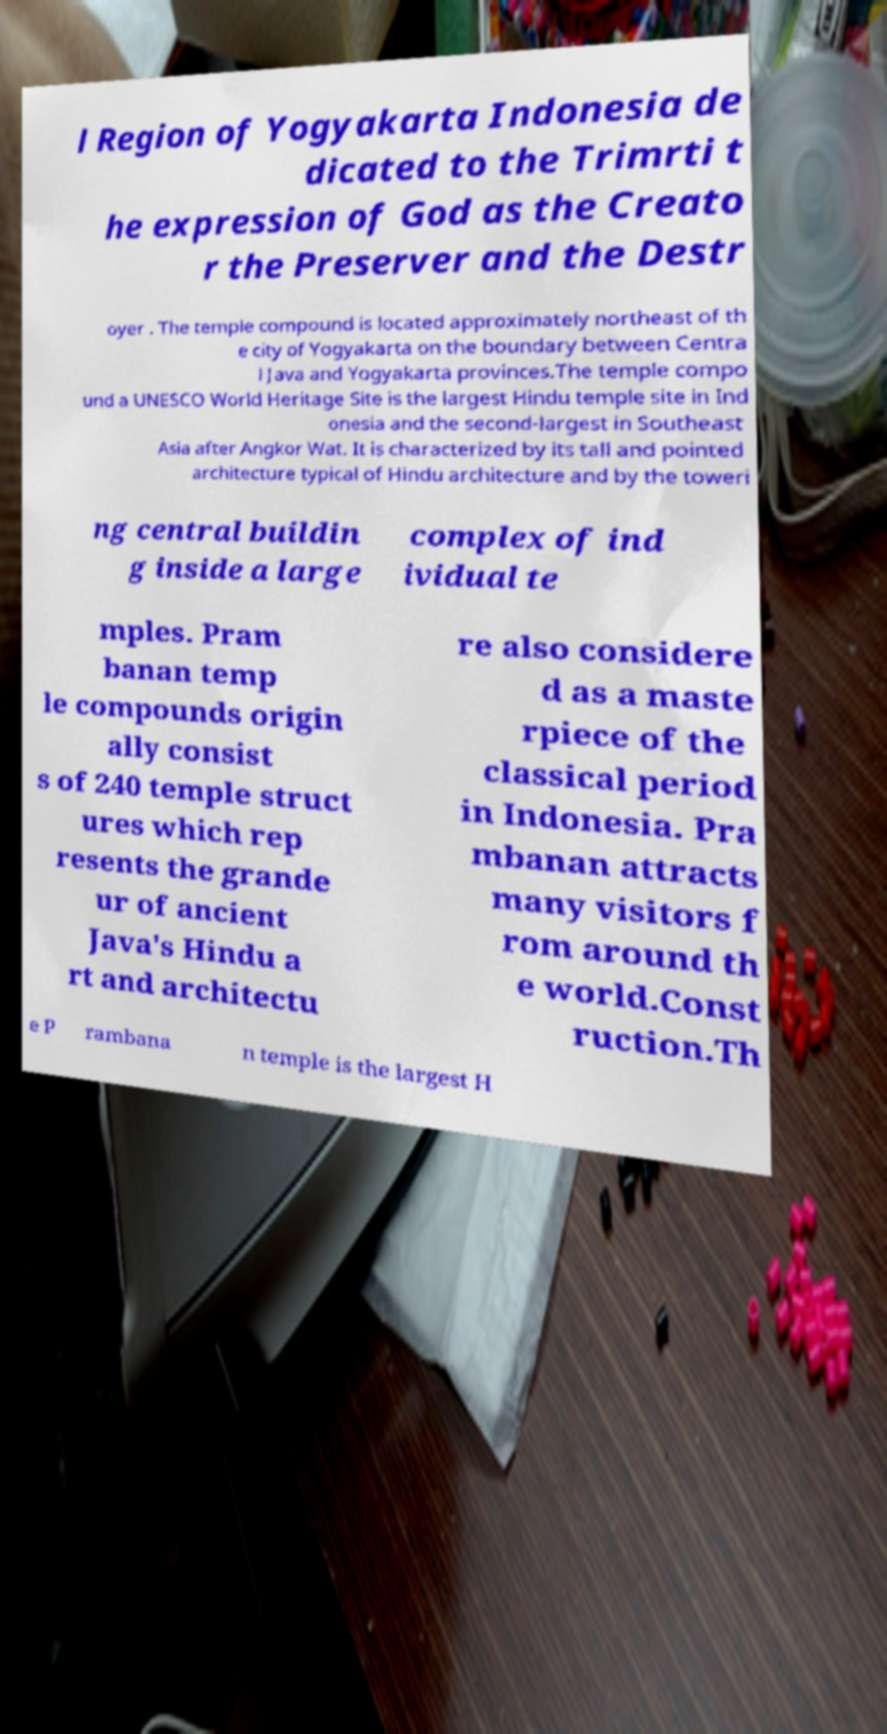Could you extract and type out the text from this image? l Region of Yogyakarta Indonesia de dicated to the Trimrti t he expression of God as the Creato r the Preserver and the Destr oyer . The temple compound is located approximately northeast of th e city of Yogyakarta on the boundary between Centra l Java and Yogyakarta provinces.The temple compo und a UNESCO World Heritage Site is the largest Hindu temple site in Ind onesia and the second-largest in Southeast Asia after Angkor Wat. It is characterized by its tall and pointed architecture typical of Hindu architecture and by the toweri ng central buildin g inside a large complex of ind ividual te mples. Pram banan temp le compounds origin ally consist s of 240 temple struct ures which rep resents the grande ur of ancient Java's Hindu a rt and architectu re also considere d as a maste rpiece of the classical period in Indonesia. Pra mbanan attracts many visitors f rom around th e world.Const ruction.Th e P rambana n temple is the largest H 